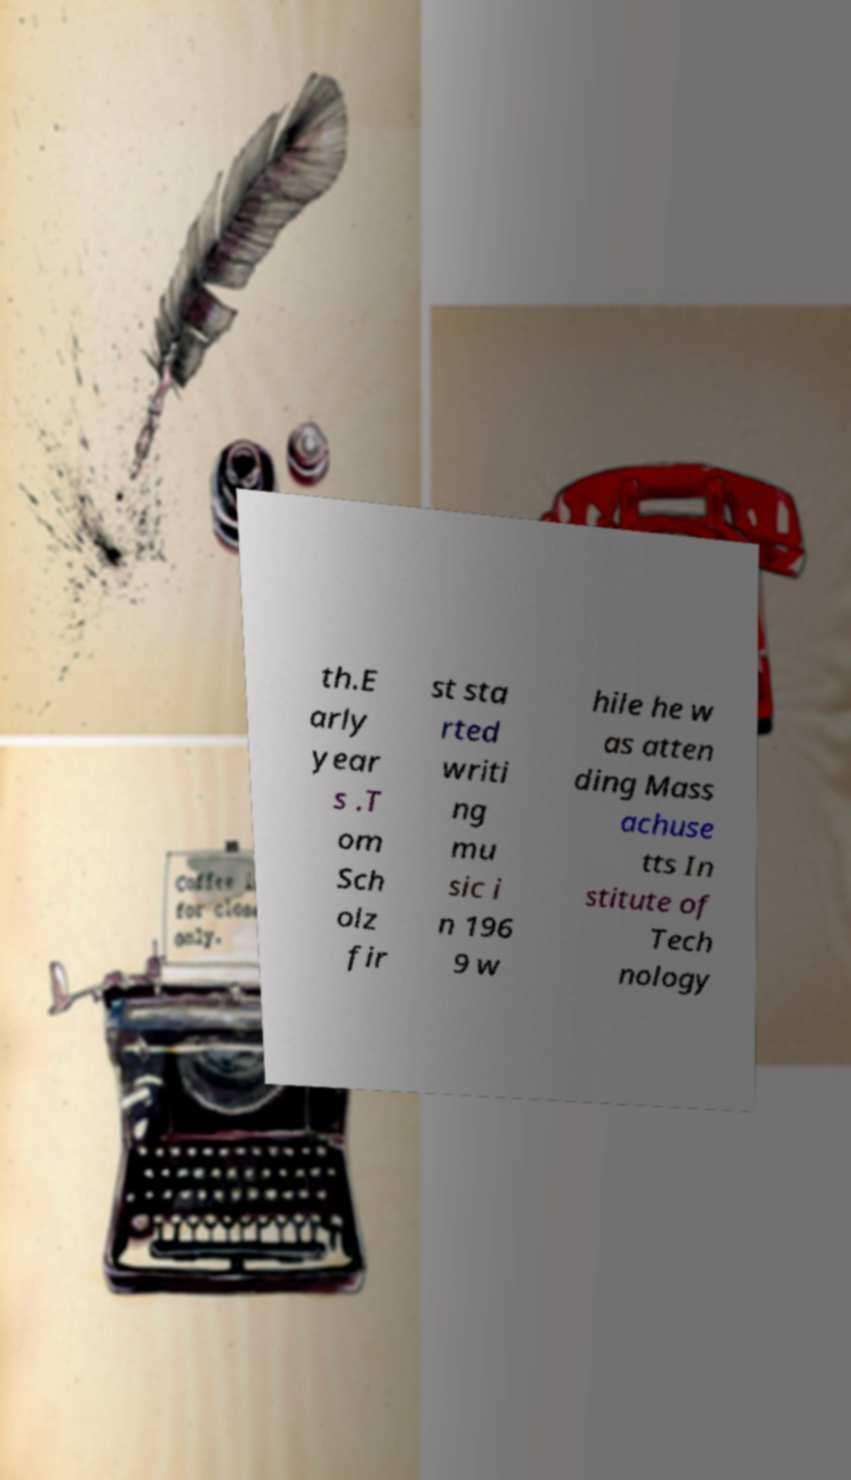What messages or text are displayed in this image? I need them in a readable, typed format. th.E arly year s .T om Sch olz fir st sta rted writi ng mu sic i n 196 9 w hile he w as atten ding Mass achuse tts In stitute of Tech nology 